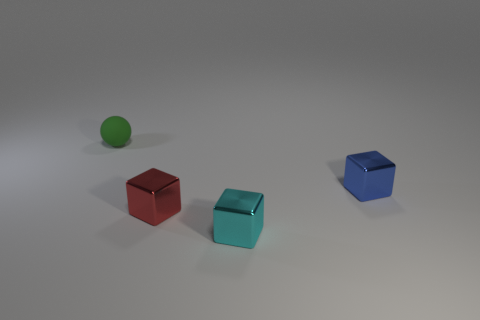Are there fewer tiny blue blocks than metallic balls?
Your answer should be very brief. No. There is a tiny object that is in front of the block to the left of the small cyan thing; what number of small blue blocks are to the right of it?
Offer a terse response. 1. There is a object that is behind the blue thing; how big is it?
Keep it short and to the point. Small. Does the metal thing that is behind the red metal thing have the same shape as the green object?
Make the answer very short. No. There is a red object that is the same shape as the cyan thing; what is its material?
Provide a short and direct response. Metal. Is there anything else that has the same size as the blue metallic cube?
Provide a succinct answer. Yes. Are there any big metal blocks?
Ensure brevity in your answer.  No. The object that is behind the small metallic block behind the small metal object to the left of the small cyan metal thing is made of what material?
Provide a short and direct response. Rubber. There is a tiny matte object; is its shape the same as the object that is on the right side of the cyan cube?
Keep it short and to the point. No. How many other small cyan objects have the same shape as the tiny cyan thing?
Keep it short and to the point. 0. 